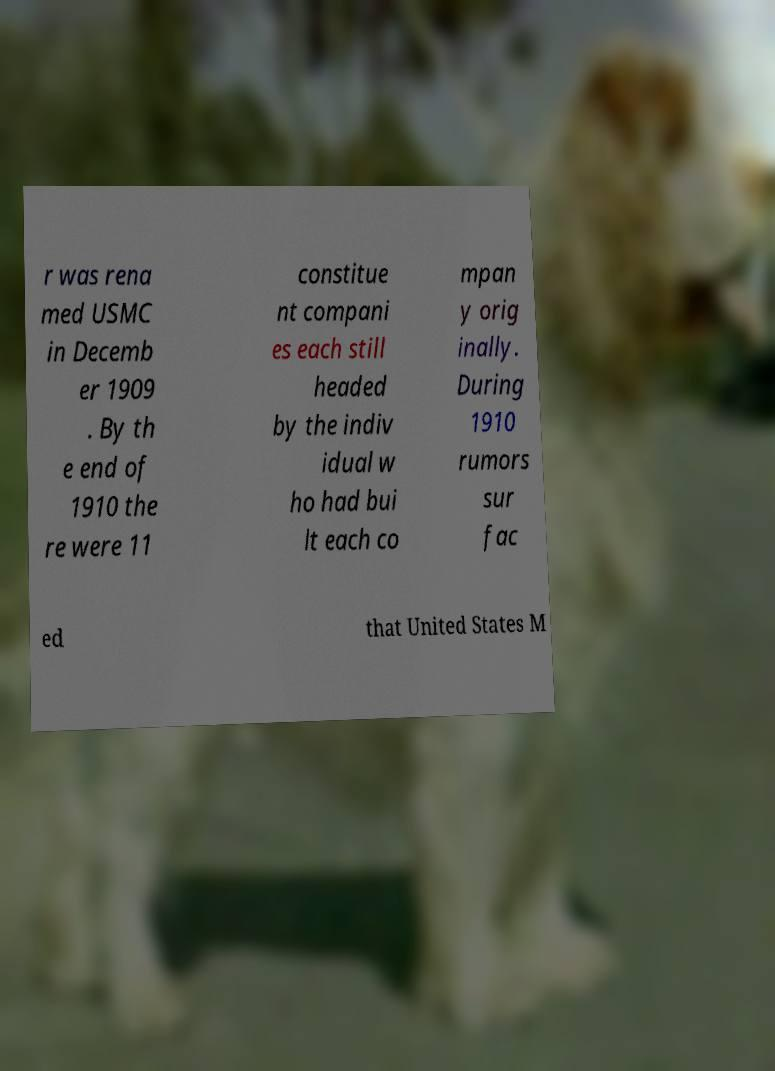For documentation purposes, I need the text within this image transcribed. Could you provide that? r was rena med USMC in Decemb er 1909 . By th e end of 1910 the re were 11 constitue nt compani es each still headed by the indiv idual w ho had bui lt each co mpan y orig inally. During 1910 rumors sur fac ed that United States M 